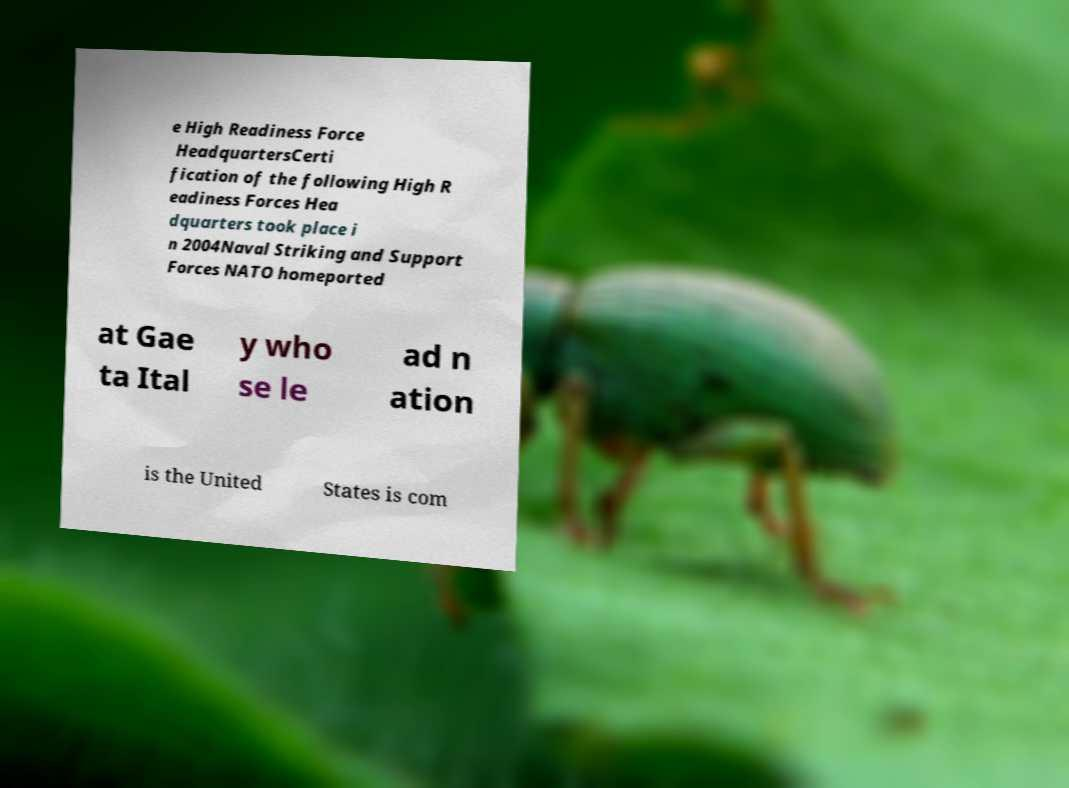I need the written content from this picture converted into text. Can you do that? e High Readiness Force HeadquartersCerti fication of the following High R eadiness Forces Hea dquarters took place i n 2004Naval Striking and Support Forces NATO homeported at Gae ta Ital y who se le ad n ation is the United States is com 